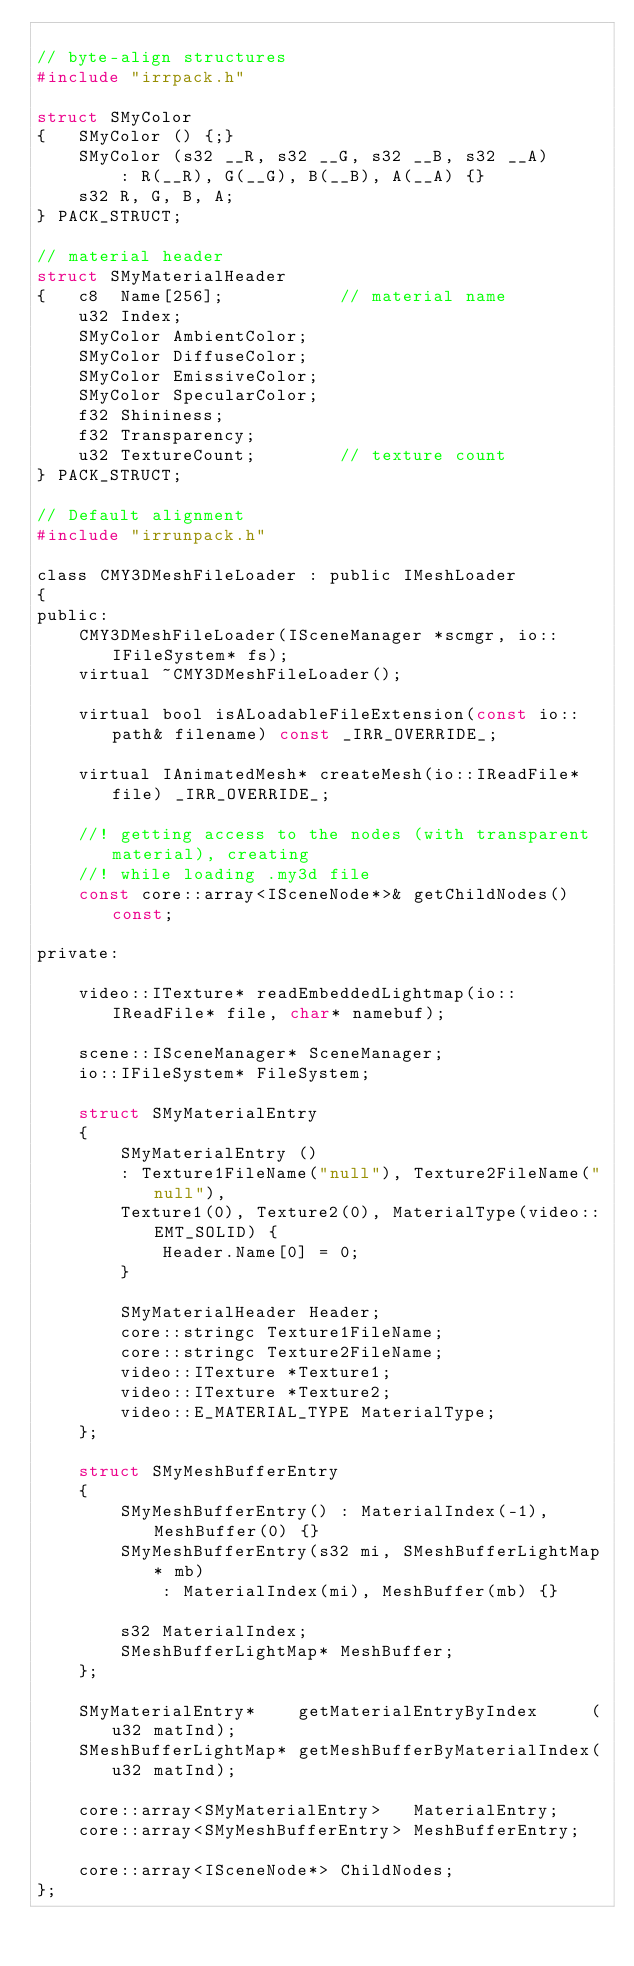<code> <loc_0><loc_0><loc_500><loc_500><_C_>
// byte-align structures
#include "irrpack.h"

struct SMyColor
{   SMyColor () {;}
    SMyColor (s32 __R, s32 __G, s32 __B, s32 __A)
        : R(__R), G(__G), B(__B), A(__A) {}
    s32 R, G, B, A;
} PACK_STRUCT;

// material header
struct SMyMaterialHeader
{   c8  Name[256];           // material name
    u32 Index;
    SMyColor AmbientColor;
    SMyColor DiffuseColor;
    SMyColor EmissiveColor;
    SMyColor SpecularColor;
    f32 Shininess;
    f32 Transparency;
    u32 TextureCount;        // texture count
} PACK_STRUCT;

// Default alignment
#include "irrunpack.h"

class CMY3DMeshFileLoader : public IMeshLoader
{
public:
	CMY3DMeshFileLoader(ISceneManager *scmgr, io::IFileSystem* fs);
	virtual ~CMY3DMeshFileLoader();

	virtual bool isALoadableFileExtension(const io::path& filename) const _IRR_OVERRIDE_;

	virtual IAnimatedMesh* createMesh(io::IReadFile* file) _IRR_OVERRIDE_;

	//! getting access to the nodes (with transparent material), creating
	//! while loading .my3d file
	const core::array<ISceneNode*>& getChildNodes() const;

private:

	video::ITexture* readEmbeddedLightmap(io::IReadFile* file, char* namebuf);

	scene::ISceneManager* SceneManager;
	io::IFileSystem* FileSystem;

	struct SMyMaterialEntry
	{
		SMyMaterialEntry ()
		: Texture1FileName("null"), Texture2FileName("null"),
		Texture1(0), Texture2(0), MaterialType(video::EMT_SOLID) {
			Header.Name[0] = 0;
		}

		SMyMaterialHeader Header;
		core::stringc Texture1FileName;
		core::stringc Texture2FileName;
		video::ITexture *Texture1;
		video::ITexture *Texture2;
		video::E_MATERIAL_TYPE MaterialType;
	};

	struct SMyMeshBufferEntry
	{
		SMyMeshBufferEntry() : MaterialIndex(-1), MeshBuffer(0) {}
		SMyMeshBufferEntry(s32 mi, SMeshBufferLightMap* mb)
			: MaterialIndex(mi), MeshBuffer(mb) {}

		s32 MaterialIndex;
		SMeshBufferLightMap* MeshBuffer;
	};

	SMyMaterialEntry*    getMaterialEntryByIndex     (u32 matInd);
	SMeshBufferLightMap* getMeshBufferByMaterialIndex(u32 matInd);

	core::array<SMyMaterialEntry>   MaterialEntry;
	core::array<SMyMeshBufferEntry> MeshBufferEntry;

	core::array<ISceneNode*> ChildNodes;
};

</code> 